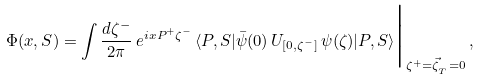Convert formula to latex. <formula><loc_0><loc_0><loc_500><loc_500>\Phi ( x , S ) = \int \frac { d \zeta ^ { - } } { 2 \pi } \, e ^ { i x P ^ { + } \zeta ^ { - } } \, \langle P , S | \bar { \psi } ( 0 ) \, U _ { [ 0 , \zeta ^ { - } ] } \, \psi ( \zeta ) | P , S \rangle \Big | _ { \zeta ^ { + } = \vec { \zeta } _ { _ { T } } = 0 } \, ,</formula> 